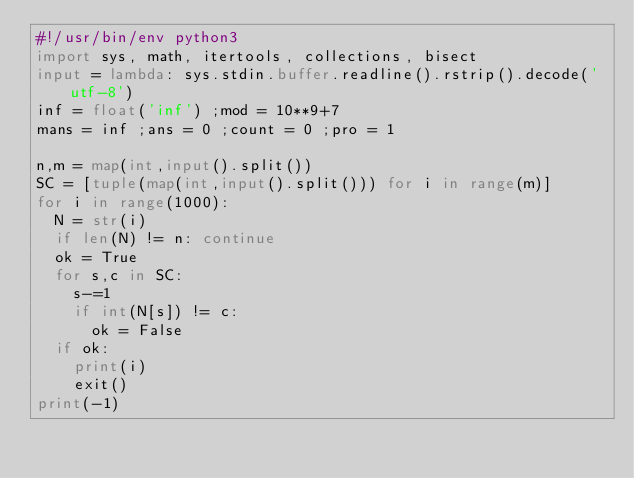<code> <loc_0><loc_0><loc_500><loc_500><_Python_>#!/usr/bin/env python3
import sys, math, itertools, collections, bisect
input = lambda: sys.stdin.buffer.readline().rstrip().decode('utf-8')
inf = float('inf') ;mod = 10**9+7
mans = inf ;ans = 0 ;count = 0 ;pro = 1

n,m = map(int,input().split())
SC = [tuple(map(int,input().split())) for i in range(m)]
for i in range(1000):
  N = str(i)
  if len(N) != n: continue
  ok = True
  for s,c in SC:
    s-=1
    if int(N[s]) != c:
      ok = False
  if ok:
    print(i)
    exit()
print(-1)
    </code> 